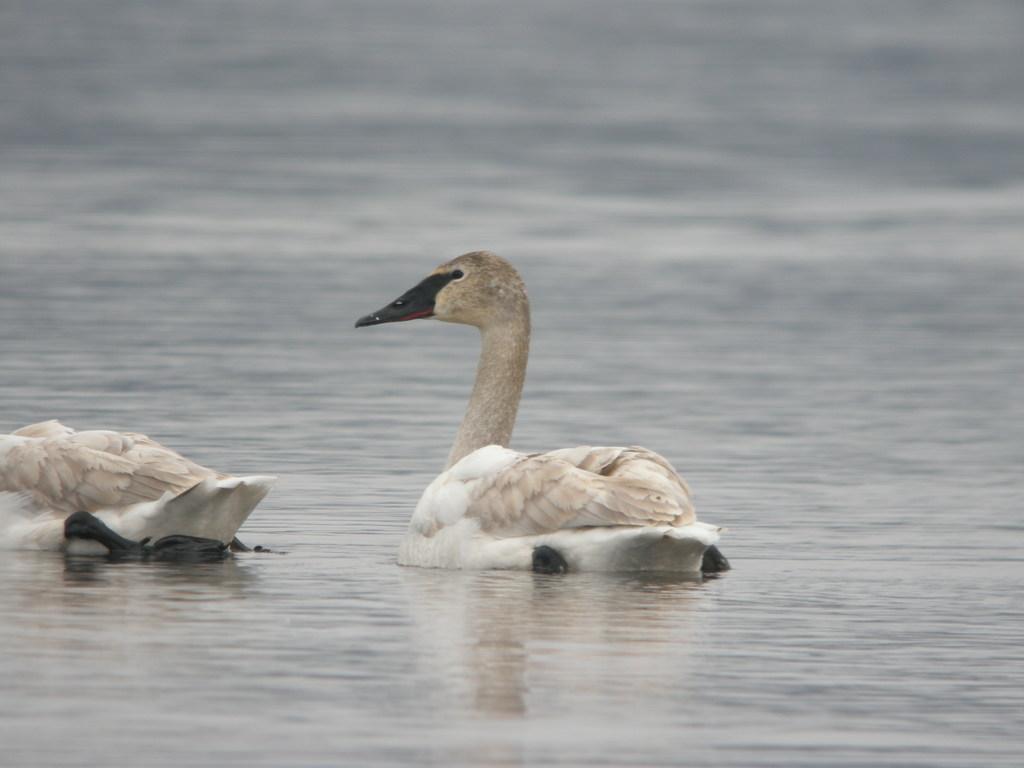In one or two sentences, can you explain what this image depicts? In this picture we have brown and white colored ducks with black beaks paddling in the river. 